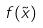<formula> <loc_0><loc_0><loc_500><loc_500>f ( \tilde { x } )</formula> 